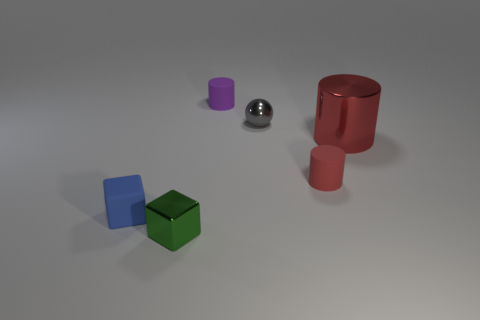There is a blue object that is the same shape as the green metallic object; what is it made of?
Offer a terse response. Rubber. What is the shape of the small shiny thing that is in front of the red cylinder that is on the right side of the red cylinder to the left of the metal cylinder?
Ensure brevity in your answer.  Cube. Are there more red metallic cylinders behind the tiny green thing than small blocks?
Offer a very short reply. No. Does the rubber object behind the red rubber thing have the same shape as the large red object?
Offer a terse response. Yes. What is the material of the small thing that is left of the green shiny block?
Ensure brevity in your answer.  Rubber. How many rubber things are the same shape as the large red metallic object?
Make the answer very short. 2. There is a tiny block on the right side of the small cube behind the small green object; what is its material?
Make the answer very short. Metal. The tiny matte object that is the same color as the large thing is what shape?
Offer a terse response. Cylinder. Is there a tiny cube that has the same material as the purple object?
Provide a short and direct response. Yes. What is the shape of the tiny green metallic thing?
Keep it short and to the point. Cube. 